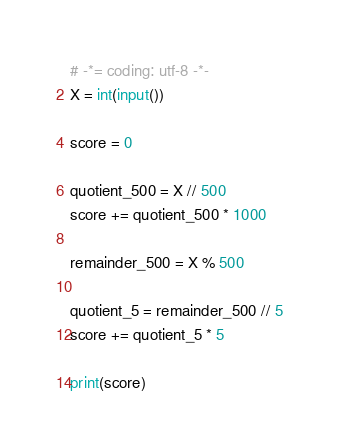<code> <loc_0><loc_0><loc_500><loc_500><_Python_># -*= coding: utf-8 -*-
X = int(input())

score = 0

quotient_500 = X // 500
score += quotient_500 * 1000

remainder_500 = X % 500

quotient_5 = remainder_500 // 5
score += quotient_5 * 5

print(score)</code> 